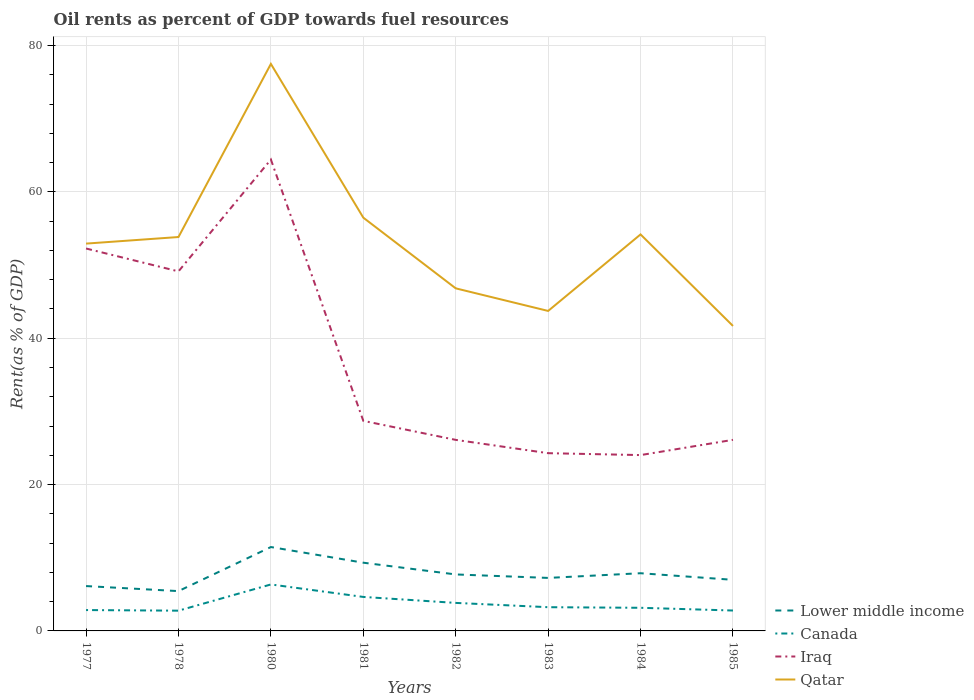How many different coloured lines are there?
Your answer should be compact. 4. Is the number of lines equal to the number of legend labels?
Provide a short and direct response. Yes. Across all years, what is the maximum oil rent in Lower middle income?
Ensure brevity in your answer.  5.44. In which year was the oil rent in Qatar maximum?
Offer a terse response. 1985. What is the total oil rent in Iraq in the graph?
Give a very brief answer. 2.6. What is the difference between the highest and the second highest oil rent in Canada?
Offer a terse response. 3.58. Is the oil rent in Iraq strictly greater than the oil rent in Lower middle income over the years?
Your answer should be compact. No. What is the difference between two consecutive major ticks on the Y-axis?
Provide a succinct answer. 20. Are the values on the major ticks of Y-axis written in scientific E-notation?
Make the answer very short. No. Does the graph contain grids?
Give a very brief answer. Yes. Where does the legend appear in the graph?
Provide a short and direct response. Bottom right. How are the legend labels stacked?
Provide a short and direct response. Vertical. What is the title of the graph?
Your answer should be very brief. Oil rents as percent of GDP towards fuel resources. What is the label or title of the Y-axis?
Provide a succinct answer. Rent(as % of GDP). What is the Rent(as % of GDP) in Lower middle income in 1977?
Offer a terse response. 6.13. What is the Rent(as % of GDP) of Canada in 1977?
Your answer should be very brief. 2.85. What is the Rent(as % of GDP) of Iraq in 1977?
Make the answer very short. 52.25. What is the Rent(as % of GDP) of Qatar in 1977?
Ensure brevity in your answer.  52.92. What is the Rent(as % of GDP) of Lower middle income in 1978?
Provide a short and direct response. 5.44. What is the Rent(as % of GDP) of Canada in 1978?
Your answer should be compact. 2.77. What is the Rent(as % of GDP) in Iraq in 1978?
Give a very brief answer. 49.13. What is the Rent(as % of GDP) of Qatar in 1978?
Ensure brevity in your answer.  53.82. What is the Rent(as % of GDP) in Lower middle income in 1980?
Provide a succinct answer. 11.46. What is the Rent(as % of GDP) in Canada in 1980?
Keep it short and to the point. 6.35. What is the Rent(as % of GDP) in Iraq in 1980?
Provide a succinct answer. 64.41. What is the Rent(as % of GDP) of Qatar in 1980?
Offer a very short reply. 77.48. What is the Rent(as % of GDP) in Lower middle income in 1981?
Give a very brief answer. 9.32. What is the Rent(as % of GDP) in Canada in 1981?
Your answer should be compact. 4.64. What is the Rent(as % of GDP) of Iraq in 1981?
Your response must be concise. 28.7. What is the Rent(as % of GDP) in Qatar in 1981?
Offer a terse response. 56.47. What is the Rent(as % of GDP) in Lower middle income in 1982?
Your response must be concise. 7.72. What is the Rent(as % of GDP) in Canada in 1982?
Your answer should be very brief. 3.83. What is the Rent(as % of GDP) in Iraq in 1982?
Ensure brevity in your answer.  26.11. What is the Rent(as % of GDP) in Qatar in 1982?
Keep it short and to the point. 46.81. What is the Rent(as % of GDP) in Lower middle income in 1983?
Provide a succinct answer. 7.24. What is the Rent(as % of GDP) in Canada in 1983?
Your answer should be compact. 3.24. What is the Rent(as % of GDP) in Iraq in 1983?
Give a very brief answer. 24.29. What is the Rent(as % of GDP) of Qatar in 1983?
Your answer should be compact. 43.72. What is the Rent(as % of GDP) in Lower middle income in 1984?
Offer a terse response. 7.88. What is the Rent(as % of GDP) in Canada in 1984?
Offer a very short reply. 3.16. What is the Rent(as % of GDP) of Iraq in 1984?
Offer a very short reply. 24.03. What is the Rent(as % of GDP) in Qatar in 1984?
Offer a terse response. 54.18. What is the Rent(as % of GDP) of Lower middle income in 1985?
Keep it short and to the point. 6.98. What is the Rent(as % of GDP) in Canada in 1985?
Offer a very short reply. 2.79. What is the Rent(as % of GDP) of Iraq in 1985?
Offer a terse response. 26.11. What is the Rent(as % of GDP) in Qatar in 1985?
Your answer should be very brief. 41.67. Across all years, what is the maximum Rent(as % of GDP) in Lower middle income?
Your response must be concise. 11.46. Across all years, what is the maximum Rent(as % of GDP) in Canada?
Your answer should be compact. 6.35. Across all years, what is the maximum Rent(as % of GDP) of Iraq?
Give a very brief answer. 64.41. Across all years, what is the maximum Rent(as % of GDP) in Qatar?
Give a very brief answer. 77.48. Across all years, what is the minimum Rent(as % of GDP) of Lower middle income?
Make the answer very short. 5.44. Across all years, what is the minimum Rent(as % of GDP) of Canada?
Your response must be concise. 2.77. Across all years, what is the minimum Rent(as % of GDP) in Iraq?
Give a very brief answer. 24.03. Across all years, what is the minimum Rent(as % of GDP) in Qatar?
Offer a very short reply. 41.67. What is the total Rent(as % of GDP) of Lower middle income in the graph?
Your answer should be very brief. 62.18. What is the total Rent(as % of GDP) in Canada in the graph?
Provide a short and direct response. 29.63. What is the total Rent(as % of GDP) of Iraq in the graph?
Provide a succinct answer. 295.03. What is the total Rent(as % of GDP) in Qatar in the graph?
Provide a succinct answer. 427.08. What is the difference between the Rent(as % of GDP) of Lower middle income in 1977 and that in 1978?
Provide a short and direct response. 0.69. What is the difference between the Rent(as % of GDP) in Canada in 1977 and that in 1978?
Give a very brief answer. 0.08. What is the difference between the Rent(as % of GDP) in Iraq in 1977 and that in 1978?
Make the answer very short. 3.13. What is the difference between the Rent(as % of GDP) in Qatar in 1977 and that in 1978?
Keep it short and to the point. -0.9. What is the difference between the Rent(as % of GDP) of Lower middle income in 1977 and that in 1980?
Give a very brief answer. -5.33. What is the difference between the Rent(as % of GDP) in Canada in 1977 and that in 1980?
Make the answer very short. -3.5. What is the difference between the Rent(as % of GDP) of Iraq in 1977 and that in 1980?
Provide a short and direct response. -12.16. What is the difference between the Rent(as % of GDP) in Qatar in 1977 and that in 1980?
Make the answer very short. -24.55. What is the difference between the Rent(as % of GDP) in Lower middle income in 1977 and that in 1981?
Make the answer very short. -3.19. What is the difference between the Rent(as % of GDP) of Canada in 1977 and that in 1981?
Provide a short and direct response. -1.79. What is the difference between the Rent(as % of GDP) of Iraq in 1977 and that in 1981?
Provide a short and direct response. 23.55. What is the difference between the Rent(as % of GDP) in Qatar in 1977 and that in 1981?
Your answer should be very brief. -3.54. What is the difference between the Rent(as % of GDP) in Lower middle income in 1977 and that in 1982?
Offer a very short reply. -1.59. What is the difference between the Rent(as % of GDP) in Canada in 1977 and that in 1982?
Give a very brief answer. -0.98. What is the difference between the Rent(as % of GDP) of Iraq in 1977 and that in 1982?
Offer a terse response. 26.15. What is the difference between the Rent(as % of GDP) of Qatar in 1977 and that in 1982?
Your answer should be very brief. 6.11. What is the difference between the Rent(as % of GDP) of Lower middle income in 1977 and that in 1983?
Ensure brevity in your answer.  -1.11. What is the difference between the Rent(as % of GDP) in Canada in 1977 and that in 1983?
Your response must be concise. -0.39. What is the difference between the Rent(as % of GDP) of Iraq in 1977 and that in 1983?
Your answer should be compact. 27.97. What is the difference between the Rent(as % of GDP) in Qatar in 1977 and that in 1983?
Offer a very short reply. 9.2. What is the difference between the Rent(as % of GDP) of Lower middle income in 1977 and that in 1984?
Your answer should be compact. -1.75. What is the difference between the Rent(as % of GDP) in Canada in 1977 and that in 1984?
Provide a succinct answer. -0.31. What is the difference between the Rent(as % of GDP) in Iraq in 1977 and that in 1984?
Ensure brevity in your answer.  28.23. What is the difference between the Rent(as % of GDP) of Qatar in 1977 and that in 1984?
Provide a succinct answer. -1.25. What is the difference between the Rent(as % of GDP) of Lower middle income in 1977 and that in 1985?
Provide a succinct answer. -0.85. What is the difference between the Rent(as % of GDP) in Canada in 1977 and that in 1985?
Provide a succinct answer. 0.06. What is the difference between the Rent(as % of GDP) of Iraq in 1977 and that in 1985?
Your response must be concise. 26.15. What is the difference between the Rent(as % of GDP) in Qatar in 1977 and that in 1985?
Your answer should be very brief. 11.25. What is the difference between the Rent(as % of GDP) of Lower middle income in 1978 and that in 1980?
Your answer should be compact. -6.02. What is the difference between the Rent(as % of GDP) in Canada in 1978 and that in 1980?
Offer a terse response. -3.58. What is the difference between the Rent(as % of GDP) in Iraq in 1978 and that in 1980?
Provide a short and direct response. -15.28. What is the difference between the Rent(as % of GDP) in Qatar in 1978 and that in 1980?
Your answer should be very brief. -23.65. What is the difference between the Rent(as % of GDP) of Lower middle income in 1978 and that in 1981?
Your answer should be very brief. -3.88. What is the difference between the Rent(as % of GDP) of Canada in 1978 and that in 1981?
Your response must be concise. -1.88. What is the difference between the Rent(as % of GDP) in Iraq in 1978 and that in 1981?
Your answer should be compact. 20.42. What is the difference between the Rent(as % of GDP) of Qatar in 1978 and that in 1981?
Offer a terse response. -2.65. What is the difference between the Rent(as % of GDP) of Lower middle income in 1978 and that in 1982?
Keep it short and to the point. -2.28. What is the difference between the Rent(as % of GDP) of Canada in 1978 and that in 1982?
Keep it short and to the point. -1.06. What is the difference between the Rent(as % of GDP) of Iraq in 1978 and that in 1982?
Make the answer very short. 23.02. What is the difference between the Rent(as % of GDP) of Qatar in 1978 and that in 1982?
Make the answer very short. 7.01. What is the difference between the Rent(as % of GDP) of Lower middle income in 1978 and that in 1983?
Make the answer very short. -1.8. What is the difference between the Rent(as % of GDP) in Canada in 1978 and that in 1983?
Provide a succinct answer. -0.47. What is the difference between the Rent(as % of GDP) in Iraq in 1978 and that in 1983?
Ensure brevity in your answer.  24.84. What is the difference between the Rent(as % of GDP) of Qatar in 1978 and that in 1983?
Your answer should be compact. 10.1. What is the difference between the Rent(as % of GDP) in Lower middle income in 1978 and that in 1984?
Your answer should be very brief. -2.44. What is the difference between the Rent(as % of GDP) of Canada in 1978 and that in 1984?
Offer a very short reply. -0.39. What is the difference between the Rent(as % of GDP) in Iraq in 1978 and that in 1984?
Provide a succinct answer. 25.1. What is the difference between the Rent(as % of GDP) in Qatar in 1978 and that in 1984?
Keep it short and to the point. -0.36. What is the difference between the Rent(as % of GDP) of Lower middle income in 1978 and that in 1985?
Provide a short and direct response. -1.54. What is the difference between the Rent(as % of GDP) of Canada in 1978 and that in 1985?
Your response must be concise. -0.02. What is the difference between the Rent(as % of GDP) in Iraq in 1978 and that in 1985?
Your answer should be compact. 23.02. What is the difference between the Rent(as % of GDP) in Qatar in 1978 and that in 1985?
Provide a short and direct response. 12.15. What is the difference between the Rent(as % of GDP) in Lower middle income in 1980 and that in 1981?
Provide a short and direct response. 2.14. What is the difference between the Rent(as % of GDP) of Canada in 1980 and that in 1981?
Your answer should be compact. 1.7. What is the difference between the Rent(as % of GDP) of Iraq in 1980 and that in 1981?
Offer a very short reply. 35.71. What is the difference between the Rent(as % of GDP) of Qatar in 1980 and that in 1981?
Keep it short and to the point. 21.01. What is the difference between the Rent(as % of GDP) of Lower middle income in 1980 and that in 1982?
Provide a short and direct response. 3.74. What is the difference between the Rent(as % of GDP) in Canada in 1980 and that in 1982?
Keep it short and to the point. 2.52. What is the difference between the Rent(as % of GDP) of Iraq in 1980 and that in 1982?
Your answer should be compact. 38.31. What is the difference between the Rent(as % of GDP) in Qatar in 1980 and that in 1982?
Make the answer very short. 30.67. What is the difference between the Rent(as % of GDP) of Lower middle income in 1980 and that in 1983?
Provide a short and direct response. 4.22. What is the difference between the Rent(as % of GDP) in Canada in 1980 and that in 1983?
Provide a succinct answer. 3.11. What is the difference between the Rent(as % of GDP) in Iraq in 1980 and that in 1983?
Offer a terse response. 40.12. What is the difference between the Rent(as % of GDP) in Qatar in 1980 and that in 1983?
Your answer should be very brief. 33.75. What is the difference between the Rent(as % of GDP) of Lower middle income in 1980 and that in 1984?
Ensure brevity in your answer.  3.58. What is the difference between the Rent(as % of GDP) of Canada in 1980 and that in 1984?
Your answer should be compact. 3.19. What is the difference between the Rent(as % of GDP) in Iraq in 1980 and that in 1984?
Your response must be concise. 40.38. What is the difference between the Rent(as % of GDP) of Qatar in 1980 and that in 1984?
Your answer should be compact. 23.3. What is the difference between the Rent(as % of GDP) in Lower middle income in 1980 and that in 1985?
Give a very brief answer. 4.48. What is the difference between the Rent(as % of GDP) of Canada in 1980 and that in 1985?
Ensure brevity in your answer.  3.56. What is the difference between the Rent(as % of GDP) of Iraq in 1980 and that in 1985?
Make the answer very short. 38.3. What is the difference between the Rent(as % of GDP) in Qatar in 1980 and that in 1985?
Provide a succinct answer. 35.81. What is the difference between the Rent(as % of GDP) of Lower middle income in 1981 and that in 1982?
Offer a very short reply. 1.6. What is the difference between the Rent(as % of GDP) of Canada in 1981 and that in 1982?
Offer a very short reply. 0.82. What is the difference between the Rent(as % of GDP) in Iraq in 1981 and that in 1982?
Your response must be concise. 2.6. What is the difference between the Rent(as % of GDP) of Qatar in 1981 and that in 1982?
Ensure brevity in your answer.  9.66. What is the difference between the Rent(as % of GDP) in Lower middle income in 1981 and that in 1983?
Your answer should be very brief. 2.08. What is the difference between the Rent(as % of GDP) of Canada in 1981 and that in 1983?
Your answer should be compact. 1.4. What is the difference between the Rent(as % of GDP) in Iraq in 1981 and that in 1983?
Keep it short and to the point. 4.42. What is the difference between the Rent(as % of GDP) in Qatar in 1981 and that in 1983?
Keep it short and to the point. 12.75. What is the difference between the Rent(as % of GDP) in Lower middle income in 1981 and that in 1984?
Your answer should be compact. 1.44. What is the difference between the Rent(as % of GDP) in Canada in 1981 and that in 1984?
Your response must be concise. 1.48. What is the difference between the Rent(as % of GDP) in Iraq in 1981 and that in 1984?
Keep it short and to the point. 4.68. What is the difference between the Rent(as % of GDP) of Qatar in 1981 and that in 1984?
Give a very brief answer. 2.29. What is the difference between the Rent(as % of GDP) in Lower middle income in 1981 and that in 1985?
Ensure brevity in your answer.  2.34. What is the difference between the Rent(as % of GDP) in Canada in 1981 and that in 1985?
Provide a succinct answer. 1.86. What is the difference between the Rent(as % of GDP) in Iraq in 1981 and that in 1985?
Provide a succinct answer. 2.6. What is the difference between the Rent(as % of GDP) of Qatar in 1981 and that in 1985?
Ensure brevity in your answer.  14.8. What is the difference between the Rent(as % of GDP) in Lower middle income in 1982 and that in 1983?
Provide a short and direct response. 0.47. What is the difference between the Rent(as % of GDP) of Canada in 1982 and that in 1983?
Provide a succinct answer. 0.59. What is the difference between the Rent(as % of GDP) in Iraq in 1982 and that in 1983?
Your response must be concise. 1.82. What is the difference between the Rent(as % of GDP) of Qatar in 1982 and that in 1983?
Ensure brevity in your answer.  3.09. What is the difference between the Rent(as % of GDP) of Lower middle income in 1982 and that in 1984?
Offer a very short reply. -0.17. What is the difference between the Rent(as % of GDP) of Canada in 1982 and that in 1984?
Provide a short and direct response. 0.67. What is the difference between the Rent(as % of GDP) in Iraq in 1982 and that in 1984?
Provide a succinct answer. 2.08. What is the difference between the Rent(as % of GDP) of Qatar in 1982 and that in 1984?
Give a very brief answer. -7.37. What is the difference between the Rent(as % of GDP) of Lower middle income in 1982 and that in 1985?
Keep it short and to the point. 0.74. What is the difference between the Rent(as % of GDP) of Canada in 1982 and that in 1985?
Provide a short and direct response. 1.04. What is the difference between the Rent(as % of GDP) of Iraq in 1982 and that in 1985?
Ensure brevity in your answer.  -0. What is the difference between the Rent(as % of GDP) in Qatar in 1982 and that in 1985?
Offer a very short reply. 5.14. What is the difference between the Rent(as % of GDP) of Lower middle income in 1983 and that in 1984?
Provide a succinct answer. -0.64. What is the difference between the Rent(as % of GDP) of Canada in 1983 and that in 1984?
Keep it short and to the point. 0.08. What is the difference between the Rent(as % of GDP) of Iraq in 1983 and that in 1984?
Your response must be concise. 0.26. What is the difference between the Rent(as % of GDP) in Qatar in 1983 and that in 1984?
Provide a succinct answer. -10.46. What is the difference between the Rent(as % of GDP) of Lower middle income in 1983 and that in 1985?
Provide a short and direct response. 0.26. What is the difference between the Rent(as % of GDP) of Canada in 1983 and that in 1985?
Give a very brief answer. 0.45. What is the difference between the Rent(as % of GDP) in Iraq in 1983 and that in 1985?
Keep it short and to the point. -1.82. What is the difference between the Rent(as % of GDP) of Qatar in 1983 and that in 1985?
Offer a very short reply. 2.05. What is the difference between the Rent(as % of GDP) in Lower middle income in 1984 and that in 1985?
Offer a very short reply. 0.9. What is the difference between the Rent(as % of GDP) in Canada in 1984 and that in 1985?
Keep it short and to the point. 0.37. What is the difference between the Rent(as % of GDP) in Iraq in 1984 and that in 1985?
Your answer should be compact. -2.08. What is the difference between the Rent(as % of GDP) in Qatar in 1984 and that in 1985?
Your response must be concise. 12.51. What is the difference between the Rent(as % of GDP) in Lower middle income in 1977 and the Rent(as % of GDP) in Canada in 1978?
Give a very brief answer. 3.36. What is the difference between the Rent(as % of GDP) of Lower middle income in 1977 and the Rent(as % of GDP) of Iraq in 1978?
Provide a succinct answer. -43. What is the difference between the Rent(as % of GDP) of Lower middle income in 1977 and the Rent(as % of GDP) of Qatar in 1978?
Offer a terse response. -47.69. What is the difference between the Rent(as % of GDP) in Canada in 1977 and the Rent(as % of GDP) in Iraq in 1978?
Your response must be concise. -46.28. What is the difference between the Rent(as % of GDP) in Canada in 1977 and the Rent(as % of GDP) in Qatar in 1978?
Give a very brief answer. -50.97. What is the difference between the Rent(as % of GDP) of Iraq in 1977 and the Rent(as % of GDP) of Qatar in 1978?
Give a very brief answer. -1.57. What is the difference between the Rent(as % of GDP) of Lower middle income in 1977 and the Rent(as % of GDP) of Canada in 1980?
Your response must be concise. -0.22. What is the difference between the Rent(as % of GDP) of Lower middle income in 1977 and the Rent(as % of GDP) of Iraq in 1980?
Your answer should be compact. -58.28. What is the difference between the Rent(as % of GDP) of Lower middle income in 1977 and the Rent(as % of GDP) of Qatar in 1980?
Give a very brief answer. -71.35. What is the difference between the Rent(as % of GDP) in Canada in 1977 and the Rent(as % of GDP) in Iraq in 1980?
Your answer should be very brief. -61.56. What is the difference between the Rent(as % of GDP) in Canada in 1977 and the Rent(as % of GDP) in Qatar in 1980?
Make the answer very short. -74.63. What is the difference between the Rent(as % of GDP) of Iraq in 1977 and the Rent(as % of GDP) of Qatar in 1980?
Give a very brief answer. -25.22. What is the difference between the Rent(as % of GDP) of Lower middle income in 1977 and the Rent(as % of GDP) of Canada in 1981?
Provide a succinct answer. 1.48. What is the difference between the Rent(as % of GDP) of Lower middle income in 1977 and the Rent(as % of GDP) of Iraq in 1981?
Make the answer very short. -22.58. What is the difference between the Rent(as % of GDP) in Lower middle income in 1977 and the Rent(as % of GDP) in Qatar in 1981?
Your answer should be compact. -50.34. What is the difference between the Rent(as % of GDP) in Canada in 1977 and the Rent(as % of GDP) in Iraq in 1981?
Offer a very short reply. -25.85. What is the difference between the Rent(as % of GDP) in Canada in 1977 and the Rent(as % of GDP) in Qatar in 1981?
Give a very brief answer. -53.62. What is the difference between the Rent(as % of GDP) of Iraq in 1977 and the Rent(as % of GDP) of Qatar in 1981?
Give a very brief answer. -4.21. What is the difference between the Rent(as % of GDP) in Lower middle income in 1977 and the Rent(as % of GDP) in Canada in 1982?
Offer a very short reply. 2.3. What is the difference between the Rent(as % of GDP) in Lower middle income in 1977 and the Rent(as % of GDP) in Iraq in 1982?
Offer a terse response. -19.98. What is the difference between the Rent(as % of GDP) of Lower middle income in 1977 and the Rent(as % of GDP) of Qatar in 1982?
Give a very brief answer. -40.68. What is the difference between the Rent(as % of GDP) of Canada in 1977 and the Rent(as % of GDP) of Iraq in 1982?
Your answer should be very brief. -23.25. What is the difference between the Rent(as % of GDP) of Canada in 1977 and the Rent(as % of GDP) of Qatar in 1982?
Your answer should be compact. -43.96. What is the difference between the Rent(as % of GDP) of Iraq in 1977 and the Rent(as % of GDP) of Qatar in 1982?
Provide a short and direct response. 5.44. What is the difference between the Rent(as % of GDP) in Lower middle income in 1977 and the Rent(as % of GDP) in Canada in 1983?
Provide a short and direct response. 2.89. What is the difference between the Rent(as % of GDP) in Lower middle income in 1977 and the Rent(as % of GDP) in Iraq in 1983?
Provide a short and direct response. -18.16. What is the difference between the Rent(as % of GDP) in Lower middle income in 1977 and the Rent(as % of GDP) in Qatar in 1983?
Your answer should be compact. -37.59. What is the difference between the Rent(as % of GDP) in Canada in 1977 and the Rent(as % of GDP) in Iraq in 1983?
Your response must be concise. -21.44. What is the difference between the Rent(as % of GDP) in Canada in 1977 and the Rent(as % of GDP) in Qatar in 1983?
Offer a terse response. -40.87. What is the difference between the Rent(as % of GDP) in Iraq in 1977 and the Rent(as % of GDP) in Qatar in 1983?
Offer a very short reply. 8.53. What is the difference between the Rent(as % of GDP) in Lower middle income in 1977 and the Rent(as % of GDP) in Canada in 1984?
Provide a succinct answer. 2.97. What is the difference between the Rent(as % of GDP) in Lower middle income in 1977 and the Rent(as % of GDP) in Iraq in 1984?
Your response must be concise. -17.9. What is the difference between the Rent(as % of GDP) in Lower middle income in 1977 and the Rent(as % of GDP) in Qatar in 1984?
Ensure brevity in your answer.  -48.05. What is the difference between the Rent(as % of GDP) in Canada in 1977 and the Rent(as % of GDP) in Iraq in 1984?
Provide a succinct answer. -21.18. What is the difference between the Rent(as % of GDP) of Canada in 1977 and the Rent(as % of GDP) of Qatar in 1984?
Offer a terse response. -51.33. What is the difference between the Rent(as % of GDP) in Iraq in 1977 and the Rent(as % of GDP) in Qatar in 1984?
Give a very brief answer. -1.92. What is the difference between the Rent(as % of GDP) of Lower middle income in 1977 and the Rent(as % of GDP) of Canada in 1985?
Offer a terse response. 3.34. What is the difference between the Rent(as % of GDP) in Lower middle income in 1977 and the Rent(as % of GDP) in Iraq in 1985?
Make the answer very short. -19.98. What is the difference between the Rent(as % of GDP) of Lower middle income in 1977 and the Rent(as % of GDP) of Qatar in 1985?
Your answer should be very brief. -35.54. What is the difference between the Rent(as % of GDP) of Canada in 1977 and the Rent(as % of GDP) of Iraq in 1985?
Your answer should be very brief. -23.26. What is the difference between the Rent(as % of GDP) in Canada in 1977 and the Rent(as % of GDP) in Qatar in 1985?
Give a very brief answer. -38.82. What is the difference between the Rent(as % of GDP) in Iraq in 1977 and the Rent(as % of GDP) in Qatar in 1985?
Provide a short and direct response. 10.58. What is the difference between the Rent(as % of GDP) of Lower middle income in 1978 and the Rent(as % of GDP) of Canada in 1980?
Keep it short and to the point. -0.91. What is the difference between the Rent(as % of GDP) of Lower middle income in 1978 and the Rent(as % of GDP) of Iraq in 1980?
Your answer should be very brief. -58.97. What is the difference between the Rent(as % of GDP) in Lower middle income in 1978 and the Rent(as % of GDP) in Qatar in 1980?
Provide a succinct answer. -72.04. What is the difference between the Rent(as % of GDP) of Canada in 1978 and the Rent(as % of GDP) of Iraq in 1980?
Your answer should be compact. -61.64. What is the difference between the Rent(as % of GDP) in Canada in 1978 and the Rent(as % of GDP) in Qatar in 1980?
Give a very brief answer. -74.71. What is the difference between the Rent(as % of GDP) of Iraq in 1978 and the Rent(as % of GDP) of Qatar in 1980?
Provide a succinct answer. -28.35. What is the difference between the Rent(as % of GDP) in Lower middle income in 1978 and the Rent(as % of GDP) in Canada in 1981?
Offer a terse response. 0.8. What is the difference between the Rent(as % of GDP) of Lower middle income in 1978 and the Rent(as % of GDP) of Iraq in 1981?
Offer a very short reply. -23.26. What is the difference between the Rent(as % of GDP) in Lower middle income in 1978 and the Rent(as % of GDP) in Qatar in 1981?
Offer a very short reply. -51.03. What is the difference between the Rent(as % of GDP) in Canada in 1978 and the Rent(as % of GDP) in Iraq in 1981?
Your response must be concise. -25.94. What is the difference between the Rent(as % of GDP) in Canada in 1978 and the Rent(as % of GDP) in Qatar in 1981?
Make the answer very short. -53.7. What is the difference between the Rent(as % of GDP) of Iraq in 1978 and the Rent(as % of GDP) of Qatar in 1981?
Your answer should be compact. -7.34. What is the difference between the Rent(as % of GDP) in Lower middle income in 1978 and the Rent(as % of GDP) in Canada in 1982?
Your answer should be very brief. 1.61. What is the difference between the Rent(as % of GDP) of Lower middle income in 1978 and the Rent(as % of GDP) of Iraq in 1982?
Your answer should be very brief. -20.66. What is the difference between the Rent(as % of GDP) in Lower middle income in 1978 and the Rent(as % of GDP) in Qatar in 1982?
Keep it short and to the point. -41.37. What is the difference between the Rent(as % of GDP) of Canada in 1978 and the Rent(as % of GDP) of Iraq in 1982?
Give a very brief answer. -23.34. What is the difference between the Rent(as % of GDP) of Canada in 1978 and the Rent(as % of GDP) of Qatar in 1982?
Offer a very short reply. -44.04. What is the difference between the Rent(as % of GDP) of Iraq in 1978 and the Rent(as % of GDP) of Qatar in 1982?
Your answer should be very brief. 2.32. What is the difference between the Rent(as % of GDP) of Lower middle income in 1978 and the Rent(as % of GDP) of Canada in 1983?
Your response must be concise. 2.2. What is the difference between the Rent(as % of GDP) in Lower middle income in 1978 and the Rent(as % of GDP) in Iraq in 1983?
Make the answer very short. -18.85. What is the difference between the Rent(as % of GDP) in Lower middle income in 1978 and the Rent(as % of GDP) in Qatar in 1983?
Your answer should be compact. -38.28. What is the difference between the Rent(as % of GDP) in Canada in 1978 and the Rent(as % of GDP) in Iraq in 1983?
Keep it short and to the point. -21.52. What is the difference between the Rent(as % of GDP) in Canada in 1978 and the Rent(as % of GDP) in Qatar in 1983?
Keep it short and to the point. -40.96. What is the difference between the Rent(as % of GDP) of Iraq in 1978 and the Rent(as % of GDP) of Qatar in 1983?
Make the answer very short. 5.41. What is the difference between the Rent(as % of GDP) in Lower middle income in 1978 and the Rent(as % of GDP) in Canada in 1984?
Ensure brevity in your answer.  2.28. What is the difference between the Rent(as % of GDP) in Lower middle income in 1978 and the Rent(as % of GDP) in Iraq in 1984?
Offer a terse response. -18.59. What is the difference between the Rent(as % of GDP) in Lower middle income in 1978 and the Rent(as % of GDP) in Qatar in 1984?
Provide a short and direct response. -48.74. What is the difference between the Rent(as % of GDP) in Canada in 1978 and the Rent(as % of GDP) in Iraq in 1984?
Offer a very short reply. -21.26. What is the difference between the Rent(as % of GDP) in Canada in 1978 and the Rent(as % of GDP) in Qatar in 1984?
Make the answer very short. -51.41. What is the difference between the Rent(as % of GDP) of Iraq in 1978 and the Rent(as % of GDP) of Qatar in 1984?
Provide a succinct answer. -5.05. What is the difference between the Rent(as % of GDP) of Lower middle income in 1978 and the Rent(as % of GDP) of Canada in 1985?
Ensure brevity in your answer.  2.65. What is the difference between the Rent(as % of GDP) in Lower middle income in 1978 and the Rent(as % of GDP) in Iraq in 1985?
Your answer should be very brief. -20.67. What is the difference between the Rent(as % of GDP) of Lower middle income in 1978 and the Rent(as % of GDP) of Qatar in 1985?
Keep it short and to the point. -36.23. What is the difference between the Rent(as % of GDP) of Canada in 1978 and the Rent(as % of GDP) of Iraq in 1985?
Make the answer very short. -23.34. What is the difference between the Rent(as % of GDP) of Canada in 1978 and the Rent(as % of GDP) of Qatar in 1985?
Provide a short and direct response. -38.91. What is the difference between the Rent(as % of GDP) in Iraq in 1978 and the Rent(as % of GDP) in Qatar in 1985?
Offer a very short reply. 7.46. What is the difference between the Rent(as % of GDP) in Lower middle income in 1980 and the Rent(as % of GDP) in Canada in 1981?
Provide a short and direct response. 6.82. What is the difference between the Rent(as % of GDP) of Lower middle income in 1980 and the Rent(as % of GDP) of Iraq in 1981?
Give a very brief answer. -17.24. What is the difference between the Rent(as % of GDP) of Lower middle income in 1980 and the Rent(as % of GDP) of Qatar in 1981?
Offer a very short reply. -45.01. What is the difference between the Rent(as % of GDP) of Canada in 1980 and the Rent(as % of GDP) of Iraq in 1981?
Keep it short and to the point. -22.35. What is the difference between the Rent(as % of GDP) in Canada in 1980 and the Rent(as % of GDP) in Qatar in 1981?
Provide a succinct answer. -50.12. What is the difference between the Rent(as % of GDP) of Iraq in 1980 and the Rent(as % of GDP) of Qatar in 1981?
Keep it short and to the point. 7.94. What is the difference between the Rent(as % of GDP) in Lower middle income in 1980 and the Rent(as % of GDP) in Canada in 1982?
Give a very brief answer. 7.63. What is the difference between the Rent(as % of GDP) in Lower middle income in 1980 and the Rent(as % of GDP) in Iraq in 1982?
Ensure brevity in your answer.  -14.64. What is the difference between the Rent(as % of GDP) of Lower middle income in 1980 and the Rent(as % of GDP) of Qatar in 1982?
Give a very brief answer. -35.35. What is the difference between the Rent(as % of GDP) in Canada in 1980 and the Rent(as % of GDP) in Iraq in 1982?
Ensure brevity in your answer.  -19.76. What is the difference between the Rent(as % of GDP) of Canada in 1980 and the Rent(as % of GDP) of Qatar in 1982?
Offer a terse response. -40.46. What is the difference between the Rent(as % of GDP) of Iraq in 1980 and the Rent(as % of GDP) of Qatar in 1982?
Your answer should be compact. 17.6. What is the difference between the Rent(as % of GDP) in Lower middle income in 1980 and the Rent(as % of GDP) in Canada in 1983?
Give a very brief answer. 8.22. What is the difference between the Rent(as % of GDP) of Lower middle income in 1980 and the Rent(as % of GDP) of Iraq in 1983?
Offer a terse response. -12.83. What is the difference between the Rent(as % of GDP) of Lower middle income in 1980 and the Rent(as % of GDP) of Qatar in 1983?
Provide a succinct answer. -32.26. What is the difference between the Rent(as % of GDP) in Canada in 1980 and the Rent(as % of GDP) in Iraq in 1983?
Your answer should be compact. -17.94. What is the difference between the Rent(as % of GDP) of Canada in 1980 and the Rent(as % of GDP) of Qatar in 1983?
Make the answer very short. -37.37. What is the difference between the Rent(as % of GDP) in Iraq in 1980 and the Rent(as % of GDP) in Qatar in 1983?
Offer a very short reply. 20.69. What is the difference between the Rent(as % of GDP) in Lower middle income in 1980 and the Rent(as % of GDP) in Canada in 1984?
Provide a short and direct response. 8.3. What is the difference between the Rent(as % of GDP) of Lower middle income in 1980 and the Rent(as % of GDP) of Iraq in 1984?
Make the answer very short. -12.56. What is the difference between the Rent(as % of GDP) in Lower middle income in 1980 and the Rent(as % of GDP) in Qatar in 1984?
Provide a succinct answer. -42.72. What is the difference between the Rent(as % of GDP) of Canada in 1980 and the Rent(as % of GDP) of Iraq in 1984?
Ensure brevity in your answer.  -17.68. What is the difference between the Rent(as % of GDP) of Canada in 1980 and the Rent(as % of GDP) of Qatar in 1984?
Make the answer very short. -47.83. What is the difference between the Rent(as % of GDP) in Iraq in 1980 and the Rent(as % of GDP) in Qatar in 1984?
Give a very brief answer. 10.23. What is the difference between the Rent(as % of GDP) in Lower middle income in 1980 and the Rent(as % of GDP) in Canada in 1985?
Provide a succinct answer. 8.67. What is the difference between the Rent(as % of GDP) in Lower middle income in 1980 and the Rent(as % of GDP) in Iraq in 1985?
Give a very brief answer. -14.65. What is the difference between the Rent(as % of GDP) of Lower middle income in 1980 and the Rent(as % of GDP) of Qatar in 1985?
Provide a succinct answer. -30.21. What is the difference between the Rent(as % of GDP) in Canada in 1980 and the Rent(as % of GDP) in Iraq in 1985?
Offer a very short reply. -19.76. What is the difference between the Rent(as % of GDP) in Canada in 1980 and the Rent(as % of GDP) in Qatar in 1985?
Ensure brevity in your answer.  -35.32. What is the difference between the Rent(as % of GDP) in Iraq in 1980 and the Rent(as % of GDP) in Qatar in 1985?
Provide a succinct answer. 22.74. What is the difference between the Rent(as % of GDP) of Lower middle income in 1981 and the Rent(as % of GDP) of Canada in 1982?
Make the answer very short. 5.49. What is the difference between the Rent(as % of GDP) in Lower middle income in 1981 and the Rent(as % of GDP) in Iraq in 1982?
Your answer should be very brief. -16.78. What is the difference between the Rent(as % of GDP) of Lower middle income in 1981 and the Rent(as % of GDP) of Qatar in 1982?
Make the answer very short. -37.49. What is the difference between the Rent(as % of GDP) in Canada in 1981 and the Rent(as % of GDP) in Iraq in 1982?
Provide a succinct answer. -21.46. What is the difference between the Rent(as % of GDP) of Canada in 1981 and the Rent(as % of GDP) of Qatar in 1982?
Offer a very short reply. -42.17. What is the difference between the Rent(as % of GDP) in Iraq in 1981 and the Rent(as % of GDP) in Qatar in 1982?
Offer a terse response. -18.11. What is the difference between the Rent(as % of GDP) in Lower middle income in 1981 and the Rent(as % of GDP) in Canada in 1983?
Ensure brevity in your answer.  6.08. What is the difference between the Rent(as % of GDP) of Lower middle income in 1981 and the Rent(as % of GDP) of Iraq in 1983?
Offer a very short reply. -14.97. What is the difference between the Rent(as % of GDP) in Lower middle income in 1981 and the Rent(as % of GDP) in Qatar in 1983?
Provide a short and direct response. -34.4. What is the difference between the Rent(as % of GDP) in Canada in 1981 and the Rent(as % of GDP) in Iraq in 1983?
Ensure brevity in your answer.  -19.64. What is the difference between the Rent(as % of GDP) in Canada in 1981 and the Rent(as % of GDP) in Qatar in 1983?
Give a very brief answer. -39.08. What is the difference between the Rent(as % of GDP) of Iraq in 1981 and the Rent(as % of GDP) of Qatar in 1983?
Offer a terse response. -15.02. What is the difference between the Rent(as % of GDP) in Lower middle income in 1981 and the Rent(as % of GDP) in Canada in 1984?
Provide a succinct answer. 6.16. What is the difference between the Rent(as % of GDP) in Lower middle income in 1981 and the Rent(as % of GDP) in Iraq in 1984?
Give a very brief answer. -14.71. What is the difference between the Rent(as % of GDP) in Lower middle income in 1981 and the Rent(as % of GDP) in Qatar in 1984?
Your answer should be compact. -44.86. What is the difference between the Rent(as % of GDP) of Canada in 1981 and the Rent(as % of GDP) of Iraq in 1984?
Provide a succinct answer. -19.38. What is the difference between the Rent(as % of GDP) in Canada in 1981 and the Rent(as % of GDP) in Qatar in 1984?
Your answer should be compact. -49.53. What is the difference between the Rent(as % of GDP) of Iraq in 1981 and the Rent(as % of GDP) of Qatar in 1984?
Make the answer very short. -25.47. What is the difference between the Rent(as % of GDP) in Lower middle income in 1981 and the Rent(as % of GDP) in Canada in 1985?
Make the answer very short. 6.53. What is the difference between the Rent(as % of GDP) of Lower middle income in 1981 and the Rent(as % of GDP) of Iraq in 1985?
Ensure brevity in your answer.  -16.79. What is the difference between the Rent(as % of GDP) in Lower middle income in 1981 and the Rent(as % of GDP) in Qatar in 1985?
Give a very brief answer. -32.35. What is the difference between the Rent(as % of GDP) of Canada in 1981 and the Rent(as % of GDP) of Iraq in 1985?
Make the answer very short. -21.46. What is the difference between the Rent(as % of GDP) in Canada in 1981 and the Rent(as % of GDP) in Qatar in 1985?
Provide a succinct answer. -37.03. What is the difference between the Rent(as % of GDP) of Iraq in 1981 and the Rent(as % of GDP) of Qatar in 1985?
Your response must be concise. -12.97. What is the difference between the Rent(as % of GDP) in Lower middle income in 1982 and the Rent(as % of GDP) in Canada in 1983?
Offer a very short reply. 4.48. What is the difference between the Rent(as % of GDP) of Lower middle income in 1982 and the Rent(as % of GDP) of Iraq in 1983?
Your answer should be compact. -16.57. What is the difference between the Rent(as % of GDP) in Lower middle income in 1982 and the Rent(as % of GDP) in Qatar in 1983?
Your response must be concise. -36.01. What is the difference between the Rent(as % of GDP) in Canada in 1982 and the Rent(as % of GDP) in Iraq in 1983?
Offer a terse response. -20.46. What is the difference between the Rent(as % of GDP) of Canada in 1982 and the Rent(as % of GDP) of Qatar in 1983?
Make the answer very short. -39.89. What is the difference between the Rent(as % of GDP) of Iraq in 1982 and the Rent(as % of GDP) of Qatar in 1983?
Your answer should be compact. -17.62. What is the difference between the Rent(as % of GDP) of Lower middle income in 1982 and the Rent(as % of GDP) of Canada in 1984?
Make the answer very short. 4.56. What is the difference between the Rent(as % of GDP) in Lower middle income in 1982 and the Rent(as % of GDP) in Iraq in 1984?
Make the answer very short. -16.31. What is the difference between the Rent(as % of GDP) in Lower middle income in 1982 and the Rent(as % of GDP) in Qatar in 1984?
Make the answer very short. -46.46. What is the difference between the Rent(as % of GDP) in Canada in 1982 and the Rent(as % of GDP) in Iraq in 1984?
Your answer should be compact. -20.2. What is the difference between the Rent(as % of GDP) in Canada in 1982 and the Rent(as % of GDP) in Qatar in 1984?
Provide a short and direct response. -50.35. What is the difference between the Rent(as % of GDP) of Iraq in 1982 and the Rent(as % of GDP) of Qatar in 1984?
Offer a very short reply. -28.07. What is the difference between the Rent(as % of GDP) in Lower middle income in 1982 and the Rent(as % of GDP) in Canada in 1985?
Ensure brevity in your answer.  4.93. What is the difference between the Rent(as % of GDP) in Lower middle income in 1982 and the Rent(as % of GDP) in Iraq in 1985?
Make the answer very short. -18.39. What is the difference between the Rent(as % of GDP) of Lower middle income in 1982 and the Rent(as % of GDP) of Qatar in 1985?
Ensure brevity in your answer.  -33.95. What is the difference between the Rent(as % of GDP) of Canada in 1982 and the Rent(as % of GDP) of Iraq in 1985?
Your answer should be very brief. -22.28. What is the difference between the Rent(as % of GDP) in Canada in 1982 and the Rent(as % of GDP) in Qatar in 1985?
Make the answer very short. -37.84. What is the difference between the Rent(as % of GDP) in Iraq in 1982 and the Rent(as % of GDP) in Qatar in 1985?
Ensure brevity in your answer.  -15.57. What is the difference between the Rent(as % of GDP) in Lower middle income in 1983 and the Rent(as % of GDP) in Canada in 1984?
Your answer should be compact. 4.08. What is the difference between the Rent(as % of GDP) of Lower middle income in 1983 and the Rent(as % of GDP) of Iraq in 1984?
Keep it short and to the point. -16.78. What is the difference between the Rent(as % of GDP) in Lower middle income in 1983 and the Rent(as % of GDP) in Qatar in 1984?
Your response must be concise. -46.94. What is the difference between the Rent(as % of GDP) in Canada in 1983 and the Rent(as % of GDP) in Iraq in 1984?
Ensure brevity in your answer.  -20.79. What is the difference between the Rent(as % of GDP) in Canada in 1983 and the Rent(as % of GDP) in Qatar in 1984?
Give a very brief answer. -50.94. What is the difference between the Rent(as % of GDP) of Iraq in 1983 and the Rent(as % of GDP) of Qatar in 1984?
Give a very brief answer. -29.89. What is the difference between the Rent(as % of GDP) in Lower middle income in 1983 and the Rent(as % of GDP) in Canada in 1985?
Ensure brevity in your answer.  4.46. What is the difference between the Rent(as % of GDP) of Lower middle income in 1983 and the Rent(as % of GDP) of Iraq in 1985?
Ensure brevity in your answer.  -18.87. What is the difference between the Rent(as % of GDP) of Lower middle income in 1983 and the Rent(as % of GDP) of Qatar in 1985?
Your response must be concise. -34.43. What is the difference between the Rent(as % of GDP) in Canada in 1983 and the Rent(as % of GDP) in Iraq in 1985?
Make the answer very short. -22.87. What is the difference between the Rent(as % of GDP) in Canada in 1983 and the Rent(as % of GDP) in Qatar in 1985?
Provide a short and direct response. -38.43. What is the difference between the Rent(as % of GDP) of Iraq in 1983 and the Rent(as % of GDP) of Qatar in 1985?
Offer a terse response. -17.38. What is the difference between the Rent(as % of GDP) of Lower middle income in 1984 and the Rent(as % of GDP) of Canada in 1985?
Your answer should be very brief. 5.1. What is the difference between the Rent(as % of GDP) in Lower middle income in 1984 and the Rent(as % of GDP) in Iraq in 1985?
Ensure brevity in your answer.  -18.23. What is the difference between the Rent(as % of GDP) in Lower middle income in 1984 and the Rent(as % of GDP) in Qatar in 1985?
Ensure brevity in your answer.  -33.79. What is the difference between the Rent(as % of GDP) in Canada in 1984 and the Rent(as % of GDP) in Iraq in 1985?
Your answer should be compact. -22.95. What is the difference between the Rent(as % of GDP) in Canada in 1984 and the Rent(as % of GDP) in Qatar in 1985?
Your answer should be compact. -38.51. What is the difference between the Rent(as % of GDP) of Iraq in 1984 and the Rent(as % of GDP) of Qatar in 1985?
Your response must be concise. -17.65. What is the average Rent(as % of GDP) of Lower middle income per year?
Offer a terse response. 7.77. What is the average Rent(as % of GDP) of Canada per year?
Keep it short and to the point. 3.7. What is the average Rent(as % of GDP) in Iraq per year?
Make the answer very short. 36.88. What is the average Rent(as % of GDP) of Qatar per year?
Offer a terse response. 53.39. In the year 1977, what is the difference between the Rent(as % of GDP) of Lower middle income and Rent(as % of GDP) of Canada?
Your answer should be compact. 3.28. In the year 1977, what is the difference between the Rent(as % of GDP) of Lower middle income and Rent(as % of GDP) of Iraq?
Give a very brief answer. -46.13. In the year 1977, what is the difference between the Rent(as % of GDP) of Lower middle income and Rent(as % of GDP) of Qatar?
Your answer should be very brief. -46.8. In the year 1977, what is the difference between the Rent(as % of GDP) of Canada and Rent(as % of GDP) of Iraq?
Provide a short and direct response. -49.4. In the year 1977, what is the difference between the Rent(as % of GDP) in Canada and Rent(as % of GDP) in Qatar?
Your answer should be compact. -50.07. In the year 1977, what is the difference between the Rent(as % of GDP) in Iraq and Rent(as % of GDP) in Qatar?
Your answer should be very brief. -0.67. In the year 1978, what is the difference between the Rent(as % of GDP) in Lower middle income and Rent(as % of GDP) in Canada?
Provide a succinct answer. 2.67. In the year 1978, what is the difference between the Rent(as % of GDP) of Lower middle income and Rent(as % of GDP) of Iraq?
Your answer should be very brief. -43.69. In the year 1978, what is the difference between the Rent(as % of GDP) in Lower middle income and Rent(as % of GDP) in Qatar?
Your answer should be very brief. -48.38. In the year 1978, what is the difference between the Rent(as % of GDP) of Canada and Rent(as % of GDP) of Iraq?
Keep it short and to the point. -46.36. In the year 1978, what is the difference between the Rent(as % of GDP) in Canada and Rent(as % of GDP) in Qatar?
Your response must be concise. -51.06. In the year 1978, what is the difference between the Rent(as % of GDP) of Iraq and Rent(as % of GDP) of Qatar?
Your response must be concise. -4.69. In the year 1980, what is the difference between the Rent(as % of GDP) in Lower middle income and Rent(as % of GDP) in Canada?
Provide a succinct answer. 5.11. In the year 1980, what is the difference between the Rent(as % of GDP) of Lower middle income and Rent(as % of GDP) of Iraq?
Give a very brief answer. -52.95. In the year 1980, what is the difference between the Rent(as % of GDP) in Lower middle income and Rent(as % of GDP) in Qatar?
Your response must be concise. -66.02. In the year 1980, what is the difference between the Rent(as % of GDP) in Canada and Rent(as % of GDP) in Iraq?
Give a very brief answer. -58.06. In the year 1980, what is the difference between the Rent(as % of GDP) in Canada and Rent(as % of GDP) in Qatar?
Ensure brevity in your answer.  -71.13. In the year 1980, what is the difference between the Rent(as % of GDP) of Iraq and Rent(as % of GDP) of Qatar?
Provide a short and direct response. -13.07. In the year 1981, what is the difference between the Rent(as % of GDP) in Lower middle income and Rent(as % of GDP) in Canada?
Provide a short and direct response. 4.68. In the year 1981, what is the difference between the Rent(as % of GDP) in Lower middle income and Rent(as % of GDP) in Iraq?
Make the answer very short. -19.38. In the year 1981, what is the difference between the Rent(as % of GDP) of Lower middle income and Rent(as % of GDP) of Qatar?
Give a very brief answer. -47.15. In the year 1981, what is the difference between the Rent(as % of GDP) of Canada and Rent(as % of GDP) of Iraq?
Your answer should be compact. -24.06. In the year 1981, what is the difference between the Rent(as % of GDP) of Canada and Rent(as % of GDP) of Qatar?
Your response must be concise. -51.82. In the year 1981, what is the difference between the Rent(as % of GDP) of Iraq and Rent(as % of GDP) of Qatar?
Your answer should be compact. -27.76. In the year 1982, what is the difference between the Rent(as % of GDP) of Lower middle income and Rent(as % of GDP) of Canada?
Make the answer very short. 3.89. In the year 1982, what is the difference between the Rent(as % of GDP) of Lower middle income and Rent(as % of GDP) of Iraq?
Your answer should be very brief. -18.39. In the year 1982, what is the difference between the Rent(as % of GDP) in Lower middle income and Rent(as % of GDP) in Qatar?
Your response must be concise. -39.09. In the year 1982, what is the difference between the Rent(as % of GDP) of Canada and Rent(as % of GDP) of Iraq?
Make the answer very short. -22.28. In the year 1982, what is the difference between the Rent(as % of GDP) of Canada and Rent(as % of GDP) of Qatar?
Give a very brief answer. -42.98. In the year 1982, what is the difference between the Rent(as % of GDP) in Iraq and Rent(as % of GDP) in Qatar?
Your answer should be compact. -20.71. In the year 1983, what is the difference between the Rent(as % of GDP) in Lower middle income and Rent(as % of GDP) in Canada?
Keep it short and to the point. 4. In the year 1983, what is the difference between the Rent(as % of GDP) in Lower middle income and Rent(as % of GDP) in Iraq?
Make the answer very short. -17.04. In the year 1983, what is the difference between the Rent(as % of GDP) of Lower middle income and Rent(as % of GDP) of Qatar?
Provide a short and direct response. -36.48. In the year 1983, what is the difference between the Rent(as % of GDP) in Canada and Rent(as % of GDP) in Iraq?
Your answer should be very brief. -21.05. In the year 1983, what is the difference between the Rent(as % of GDP) in Canada and Rent(as % of GDP) in Qatar?
Give a very brief answer. -40.48. In the year 1983, what is the difference between the Rent(as % of GDP) in Iraq and Rent(as % of GDP) in Qatar?
Give a very brief answer. -19.44. In the year 1984, what is the difference between the Rent(as % of GDP) in Lower middle income and Rent(as % of GDP) in Canada?
Give a very brief answer. 4.72. In the year 1984, what is the difference between the Rent(as % of GDP) in Lower middle income and Rent(as % of GDP) in Iraq?
Offer a terse response. -16.14. In the year 1984, what is the difference between the Rent(as % of GDP) of Lower middle income and Rent(as % of GDP) of Qatar?
Your answer should be compact. -46.3. In the year 1984, what is the difference between the Rent(as % of GDP) of Canada and Rent(as % of GDP) of Iraq?
Provide a succinct answer. -20.87. In the year 1984, what is the difference between the Rent(as % of GDP) in Canada and Rent(as % of GDP) in Qatar?
Offer a terse response. -51.02. In the year 1984, what is the difference between the Rent(as % of GDP) of Iraq and Rent(as % of GDP) of Qatar?
Offer a terse response. -30.15. In the year 1985, what is the difference between the Rent(as % of GDP) in Lower middle income and Rent(as % of GDP) in Canada?
Ensure brevity in your answer.  4.19. In the year 1985, what is the difference between the Rent(as % of GDP) of Lower middle income and Rent(as % of GDP) of Iraq?
Offer a terse response. -19.13. In the year 1985, what is the difference between the Rent(as % of GDP) of Lower middle income and Rent(as % of GDP) of Qatar?
Keep it short and to the point. -34.69. In the year 1985, what is the difference between the Rent(as % of GDP) in Canada and Rent(as % of GDP) in Iraq?
Your answer should be very brief. -23.32. In the year 1985, what is the difference between the Rent(as % of GDP) of Canada and Rent(as % of GDP) of Qatar?
Your response must be concise. -38.88. In the year 1985, what is the difference between the Rent(as % of GDP) in Iraq and Rent(as % of GDP) in Qatar?
Provide a succinct answer. -15.56. What is the ratio of the Rent(as % of GDP) in Lower middle income in 1977 to that in 1978?
Give a very brief answer. 1.13. What is the ratio of the Rent(as % of GDP) of Canada in 1977 to that in 1978?
Offer a very short reply. 1.03. What is the ratio of the Rent(as % of GDP) of Iraq in 1977 to that in 1978?
Offer a very short reply. 1.06. What is the ratio of the Rent(as % of GDP) in Qatar in 1977 to that in 1978?
Provide a short and direct response. 0.98. What is the ratio of the Rent(as % of GDP) in Lower middle income in 1977 to that in 1980?
Your response must be concise. 0.53. What is the ratio of the Rent(as % of GDP) in Canada in 1977 to that in 1980?
Your response must be concise. 0.45. What is the ratio of the Rent(as % of GDP) of Iraq in 1977 to that in 1980?
Provide a short and direct response. 0.81. What is the ratio of the Rent(as % of GDP) of Qatar in 1977 to that in 1980?
Ensure brevity in your answer.  0.68. What is the ratio of the Rent(as % of GDP) in Lower middle income in 1977 to that in 1981?
Make the answer very short. 0.66. What is the ratio of the Rent(as % of GDP) of Canada in 1977 to that in 1981?
Ensure brevity in your answer.  0.61. What is the ratio of the Rent(as % of GDP) of Iraq in 1977 to that in 1981?
Give a very brief answer. 1.82. What is the ratio of the Rent(as % of GDP) in Qatar in 1977 to that in 1981?
Give a very brief answer. 0.94. What is the ratio of the Rent(as % of GDP) in Lower middle income in 1977 to that in 1982?
Make the answer very short. 0.79. What is the ratio of the Rent(as % of GDP) of Canada in 1977 to that in 1982?
Give a very brief answer. 0.74. What is the ratio of the Rent(as % of GDP) in Iraq in 1977 to that in 1982?
Provide a succinct answer. 2. What is the ratio of the Rent(as % of GDP) of Qatar in 1977 to that in 1982?
Ensure brevity in your answer.  1.13. What is the ratio of the Rent(as % of GDP) of Lower middle income in 1977 to that in 1983?
Offer a terse response. 0.85. What is the ratio of the Rent(as % of GDP) in Canada in 1977 to that in 1983?
Offer a very short reply. 0.88. What is the ratio of the Rent(as % of GDP) of Iraq in 1977 to that in 1983?
Provide a succinct answer. 2.15. What is the ratio of the Rent(as % of GDP) of Qatar in 1977 to that in 1983?
Your answer should be compact. 1.21. What is the ratio of the Rent(as % of GDP) of Lower middle income in 1977 to that in 1984?
Offer a very short reply. 0.78. What is the ratio of the Rent(as % of GDP) of Canada in 1977 to that in 1984?
Provide a succinct answer. 0.9. What is the ratio of the Rent(as % of GDP) in Iraq in 1977 to that in 1984?
Offer a very short reply. 2.17. What is the ratio of the Rent(as % of GDP) in Qatar in 1977 to that in 1984?
Offer a very short reply. 0.98. What is the ratio of the Rent(as % of GDP) of Lower middle income in 1977 to that in 1985?
Make the answer very short. 0.88. What is the ratio of the Rent(as % of GDP) of Canada in 1977 to that in 1985?
Give a very brief answer. 1.02. What is the ratio of the Rent(as % of GDP) in Iraq in 1977 to that in 1985?
Your answer should be very brief. 2. What is the ratio of the Rent(as % of GDP) in Qatar in 1977 to that in 1985?
Offer a very short reply. 1.27. What is the ratio of the Rent(as % of GDP) in Lower middle income in 1978 to that in 1980?
Give a very brief answer. 0.47. What is the ratio of the Rent(as % of GDP) of Canada in 1978 to that in 1980?
Give a very brief answer. 0.44. What is the ratio of the Rent(as % of GDP) of Iraq in 1978 to that in 1980?
Ensure brevity in your answer.  0.76. What is the ratio of the Rent(as % of GDP) of Qatar in 1978 to that in 1980?
Your response must be concise. 0.69. What is the ratio of the Rent(as % of GDP) of Lower middle income in 1978 to that in 1981?
Offer a very short reply. 0.58. What is the ratio of the Rent(as % of GDP) in Canada in 1978 to that in 1981?
Your response must be concise. 0.6. What is the ratio of the Rent(as % of GDP) in Iraq in 1978 to that in 1981?
Your answer should be compact. 1.71. What is the ratio of the Rent(as % of GDP) of Qatar in 1978 to that in 1981?
Ensure brevity in your answer.  0.95. What is the ratio of the Rent(as % of GDP) in Lower middle income in 1978 to that in 1982?
Provide a short and direct response. 0.7. What is the ratio of the Rent(as % of GDP) in Canada in 1978 to that in 1982?
Offer a terse response. 0.72. What is the ratio of the Rent(as % of GDP) in Iraq in 1978 to that in 1982?
Make the answer very short. 1.88. What is the ratio of the Rent(as % of GDP) in Qatar in 1978 to that in 1982?
Give a very brief answer. 1.15. What is the ratio of the Rent(as % of GDP) in Lower middle income in 1978 to that in 1983?
Your answer should be very brief. 0.75. What is the ratio of the Rent(as % of GDP) in Canada in 1978 to that in 1983?
Make the answer very short. 0.85. What is the ratio of the Rent(as % of GDP) of Iraq in 1978 to that in 1983?
Your response must be concise. 2.02. What is the ratio of the Rent(as % of GDP) in Qatar in 1978 to that in 1983?
Provide a succinct answer. 1.23. What is the ratio of the Rent(as % of GDP) in Lower middle income in 1978 to that in 1984?
Provide a short and direct response. 0.69. What is the ratio of the Rent(as % of GDP) of Canada in 1978 to that in 1984?
Your answer should be very brief. 0.88. What is the ratio of the Rent(as % of GDP) of Iraq in 1978 to that in 1984?
Ensure brevity in your answer.  2.04. What is the ratio of the Rent(as % of GDP) in Qatar in 1978 to that in 1984?
Provide a succinct answer. 0.99. What is the ratio of the Rent(as % of GDP) of Lower middle income in 1978 to that in 1985?
Provide a succinct answer. 0.78. What is the ratio of the Rent(as % of GDP) of Iraq in 1978 to that in 1985?
Make the answer very short. 1.88. What is the ratio of the Rent(as % of GDP) in Qatar in 1978 to that in 1985?
Ensure brevity in your answer.  1.29. What is the ratio of the Rent(as % of GDP) of Lower middle income in 1980 to that in 1981?
Give a very brief answer. 1.23. What is the ratio of the Rent(as % of GDP) in Canada in 1980 to that in 1981?
Your response must be concise. 1.37. What is the ratio of the Rent(as % of GDP) of Iraq in 1980 to that in 1981?
Provide a short and direct response. 2.24. What is the ratio of the Rent(as % of GDP) of Qatar in 1980 to that in 1981?
Offer a very short reply. 1.37. What is the ratio of the Rent(as % of GDP) of Lower middle income in 1980 to that in 1982?
Your answer should be very brief. 1.49. What is the ratio of the Rent(as % of GDP) in Canada in 1980 to that in 1982?
Ensure brevity in your answer.  1.66. What is the ratio of the Rent(as % of GDP) in Iraq in 1980 to that in 1982?
Give a very brief answer. 2.47. What is the ratio of the Rent(as % of GDP) in Qatar in 1980 to that in 1982?
Provide a succinct answer. 1.66. What is the ratio of the Rent(as % of GDP) in Lower middle income in 1980 to that in 1983?
Ensure brevity in your answer.  1.58. What is the ratio of the Rent(as % of GDP) of Canada in 1980 to that in 1983?
Your answer should be compact. 1.96. What is the ratio of the Rent(as % of GDP) of Iraq in 1980 to that in 1983?
Your response must be concise. 2.65. What is the ratio of the Rent(as % of GDP) of Qatar in 1980 to that in 1983?
Ensure brevity in your answer.  1.77. What is the ratio of the Rent(as % of GDP) in Lower middle income in 1980 to that in 1984?
Make the answer very short. 1.45. What is the ratio of the Rent(as % of GDP) of Canada in 1980 to that in 1984?
Give a very brief answer. 2.01. What is the ratio of the Rent(as % of GDP) of Iraq in 1980 to that in 1984?
Offer a terse response. 2.68. What is the ratio of the Rent(as % of GDP) of Qatar in 1980 to that in 1984?
Ensure brevity in your answer.  1.43. What is the ratio of the Rent(as % of GDP) in Lower middle income in 1980 to that in 1985?
Make the answer very short. 1.64. What is the ratio of the Rent(as % of GDP) in Canada in 1980 to that in 1985?
Offer a terse response. 2.28. What is the ratio of the Rent(as % of GDP) of Iraq in 1980 to that in 1985?
Keep it short and to the point. 2.47. What is the ratio of the Rent(as % of GDP) in Qatar in 1980 to that in 1985?
Provide a succinct answer. 1.86. What is the ratio of the Rent(as % of GDP) in Lower middle income in 1981 to that in 1982?
Give a very brief answer. 1.21. What is the ratio of the Rent(as % of GDP) of Canada in 1981 to that in 1982?
Give a very brief answer. 1.21. What is the ratio of the Rent(as % of GDP) of Iraq in 1981 to that in 1982?
Offer a terse response. 1.1. What is the ratio of the Rent(as % of GDP) of Qatar in 1981 to that in 1982?
Your response must be concise. 1.21. What is the ratio of the Rent(as % of GDP) of Lower middle income in 1981 to that in 1983?
Your answer should be compact. 1.29. What is the ratio of the Rent(as % of GDP) of Canada in 1981 to that in 1983?
Provide a short and direct response. 1.43. What is the ratio of the Rent(as % of GDP) in Iraq in 1981 to that in 1983?
Provide a short and direct response. 1.18. What is the ratio of the Rent(as % of GDP) of Qatar in 1981 to that in 1983?
Give a very brief answer. 1.29. What is the ratio of the Rent(as % of GDP) in Lower middle income in 1981 to that in 1984?
Your answer should be very brief. 1.18. What is the ratio of the Rent(as % of GDP) of Canada in 1981 to that in 1984?
Offer a terse response. 1.47. What is the ratio of the Rent(as % of GDP) of Iraq in 1981 to that in 1984?
Make the answer very short. 1.19. What is the ratio of the Rent(as % of GDP) of Qatar in 1981 to that in 1984?
Your answer should be very brief. 1.04. What is the ratio of the Rent(as % of GDP) of Lower middle income in 1981 to that in 1985?
Offer a very short reply. 1.33. What is the ratio of the Rent(as % of GDP) in Canada in 1981 to that in 1985?
Your answer should be very brief. 1.67. What is the ratio of the Rent(as % of GDP) in Iraq in 1981 to that in 1985?
Ensure brevity in your answer.  1.1. What is the ratio of the Rent(as % of GDP) in Qatar in 1981 to that in 1985?
Ensure brevity in your answer.  1.36. What is the ratio of the Rent(as % of GDP) of Lower middle income in 1982 to that in 1983?
Provide a short and direct response. 1.07. What is the ratio of the Rent(as % of GDP) in Canada in 1982 to that in 1983?
Your response must be concise. 1.18. What is the ratio of the Rent(as % of GDP) in Iraq in 1982 to that in 1983?
Provide a short and direct response. 1.07. What is the ratio of the Rent(as % of GDP) in Qatar in 1982 to that in 1983?
Your response must be concise. 1.07. What is the ratio of the Rent(as % of GDP) of Lower middle income in 1982 to that in 1984?
Offer a terse response. 0.98. What is the ratio of the Rent(as % of GDP) of Canada in 1982 to that in 1984?
Provide a short and direct response. 1.21. What is the ratio of the Rent(as % of GDP) in Iraq in 1982 to that in 1984?
Offer a terse response. 1.09. What is the ratio of the Rent(as % of GDP) in Qatar in 1982 to that in 1984?
Your response must be concise. 0.86. What is the ratio of the Rent(as % of GDP) in Lower middle income in 1982 to that in 1985?
Give a very brief answer. 1.11. What is the ratio of the Rent(as % of GDP) of Canada in 1982 to that in 1985?
Provide a succinct answer. 1.37. What is the ratio of the Rent(as % of GDP) of Qatar in 1982 to that in 1985?
Your answer should be very brief. 1.12. What is the ratio of the Rent(as % of GDP) of Lower middle income in 1983 to that in 1984?
Ensure brevity in your answer.  0.92. What is the ratio of the Rent(as % of GDP) of Canada in 1983 to that in 1984?
Give a very brief answer. 1.03. What is the ratio of the Rent(as % of GDP) in Iraq in 1983 to that in 1984?
Offer a very short reply. 1.01. What is the ratio of the Rent(as % of GDP) of Qatar in 1983 to that in 1984?
Ensure brevity in your answer.  0.81. What is the ratio of the Rent(as % of GDP) of Lower middle income in 1983 to that in 1985?
Your response must be concise. 1.04. What is the ratio of the Rent(as % of GDP) in Canada in 1983 to that in 1985?
Your answer should be compact. 1.16. What is the ratio of the Rent(as % of GDP) in Iraq in 1983 to that in 1985?
Your answer should be very brief. 0.93. What is the ratio of the Rent(as % of GDP) of Qatar in 1983 to that in 1985?
Ensure brevity in your answer.  1.05. What is the ratio of the Rent(as % of GDP) of Lower middle income in 1984 to that in 1985?
Make the answer very short. 1.13. What is the ratio of the Rent(as % of GDP) of Canada in 1984 to that in 1985?
Ensure brevity in your answer.  1.13. What is the ratio of the Rent(as % of GDP) of Iraq in 1984 to that in 1985?
Offer a very short reply. 0.92. What is the ratio of the Rent(as % of GDP) in Qatar in 1984 to that in 1985?
Your answer should be very brief. 1.3. What is the difference between the highest and the second highest Rent(as % of GDP) in Lower middle income?
Your answer should be compact. 2.14. What is the difference between the highest and the second highest Rent(as % of GDP) of Canada?
Keep it short and to the point. 1.7. What is the difference between the highest and the second highest Rent(as % of GDP) of Iraq?
Give a very brief answer. 12.16. What is the difference between the highest and the second highest Rent(as % of GDP) of Qatar?
Your answer should be compact. 21.01. What is the difference between the highest and the lowest Rent(as % of GDP) in Lower middle income?
Your answer should be very brief. 6.02. What is the difference between the highest and the lowest Rent(as % of GDP) in Canada?
Provide a short and direct response. 3.58. What is the difference between the highest and the lowest Rent(as % of GDP) of Iraq?
Offer a terse response. 40.38. What is the difference between the highest and the lowest Rent(as % of GDP) in Qatar?
Provide a succinct answer. 35.81. 